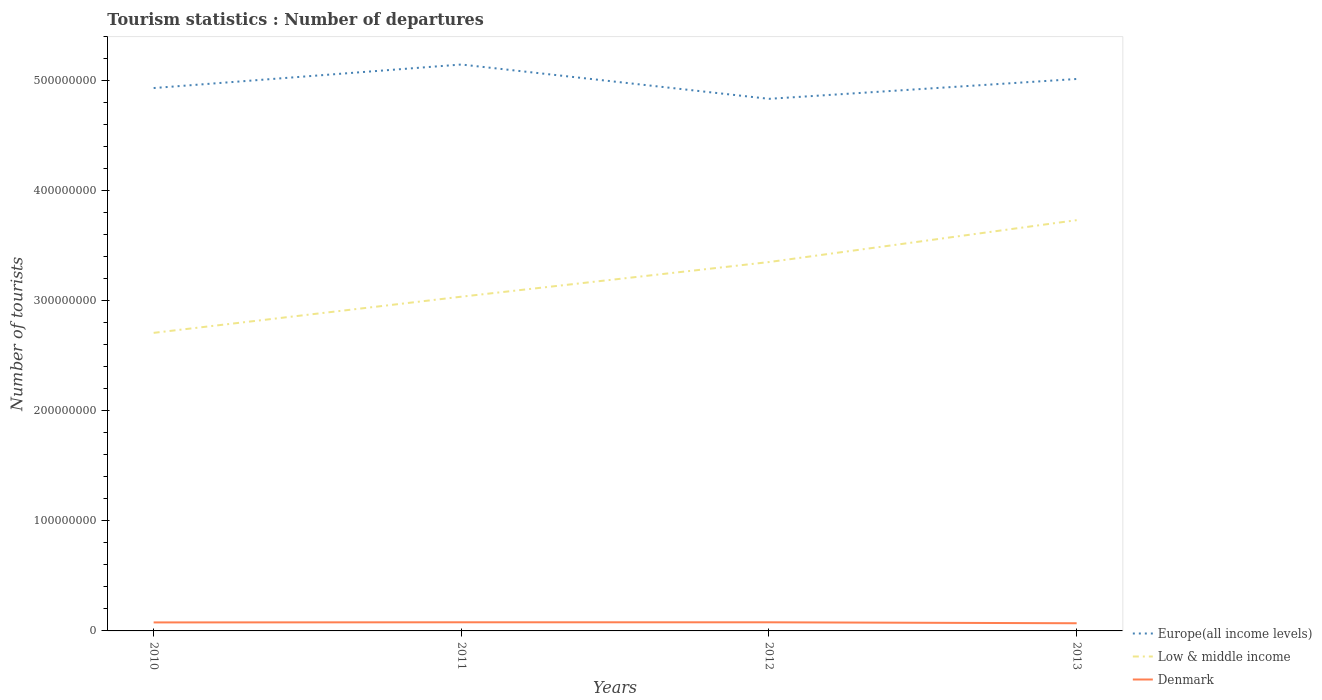Does the line corresponding to Denmark intersect with the line corresponding to Low & middle income?
Provide a succinct answer. No. Across all years, what is the maximum number of tourist departures in Europe(all income levels)?
Offer a very short reply. 4.84e+08. What is the total number of tourist departures in Low & middle income in the graph?
Provide a succinct answer. -6.96e+07. What is the difference between the highest and the second highest number of tourist departures in Denmark?
Offer a very short reply. 8.69e+05. What is the difference between the highest and the lowest number of tourist departures in Europe(all income levels)?
Ensure brevity in your answer.  2. How many lines are there?
Your answer should be compact. 3. How many years are there in the graph?
Make the answer very short. 4. Are the values on the major ticks of Y-axis written in scientific E-notation?
Your answer should be compact. No. Where does the legend appear in the graph?
Ensure brevity in your answer.  Bottom right. How are the legend labels stacked?
Ensure brevity in your answer.  Vertical. What is the title of the graph?
Give a very brief answer. Tourism statistics : Number of departures. What is the label or title of the Y-axis?
Ensure brevity in your answer.  Number of tourists. What is the Number of tourists of Europe(all income levels) in 2010?
Keep it short and to the point. 4.93e+08. What is the Number of tourists in Low & middle income in 2010?
Ensure brevity in your answer.  2.71e+08. What is the Number of tourists in Denmark in 2010?
Make the answer very short. 7.73e+06. What is the Number of tourists of Europe(all income levels) in 2011?
Ensure brevity in your answer.  5.15e+08. What is the Number of tourists in Low & middle income in 2011?
Provide a short and direct response. 3.04e+08. What is the Number of tourists of Denmark in 2011?
Your answer should be compact. 7.85e+06. What is the Number of tourists in Europe(all income levels) in 2012?
Your response must be concise. 4.84e+08. What is the Number of tourists of Low & middle income in 2012?
Ensure brevity in your answer.  3.35e+08. What is the Number of tourists of Denmark in 2012?
Keep it short and to the point. 7.84e+06. What is the Number of tourists in Europe(all income levels) in 2013?
Your answer should be compact. 5.02e+08. What is the Number of tourists in Low & middle income in 2013?
Provide a short and direct response. 3.73e+08. What is the Number of tourists of Denmark in 2013?
Give a very brief answer. 6.98e+06. Across all years, what is the maximum Number of tourists of Europe(all income levels)?
Provide a succinct answer. 5.15e+08. Across all years, what is the maximum Number of tourists in Low & middle income?
Make the answer very short. 3.73e+08. Across all years, what is the maximum Number of tourists in Denmark?
Provide a short and direct response. 7.85e+06. Across all years, what is the minimum Number of tourists in Europe(all income levels)?
Offer a very short reply. 4.84e+08. Across all years, what is the minimum Number of tourists of Low & middle income?
Your answer should be very brief. 2.71e+08. Across all years, what is the minimum Number of tourists of Denmark?
Offer a terse response. 6.98e+06. What is the total Number of tourists of Europe(all income levels) in the graph?
Your answer should be compact. 1.99e+09. What is the total Number of tourists in Low & middle income in the graph?
Your answer should be very brief. 1.28e+09. What is the total Number of tourists in Denmark in the graph?
Provide a succinct answer. 3.04e+07. What is the difference between the Number of tourists of Europe(all income levels) in 2010 and that in 2011?
Provide a succinct answer. -2.14e+07. What is the difference between the Number of tourists of Low & middle income in 2010 and that in 2011?
Provide a succinct answer. -3.29e+07. What is the difference between the Number of tourists of Denmark in 2010 and that in 2011?
Your answer should be very brief. -1.20e+05. What is the difference between the Number of tourists in Europe(all income levels) in 2010 and that in 2012?
Offer a terse response. 9.80e+06. What is the difference between the Number of tourists in Low & middle income in 2010 and that in 2012?
Make the answer very short. -6.44e+07. What is the difference between the Number of tourists in Denmark in 2010 and that in 2012?
Give a very brief answer. -1.17e+05. What is the difference between the Number of tourists in Europe(all income levels) in 2010 and that in 2013?
Make the answer very short. -8.24e+06. What is the difference between the Number of tourists of Low & middle income in 2010 and that in 2013?
Provide a short and direct response. -1.02e+08. What is the difference between the Number of tourists in Denmark in 2010 and that in 2013?
Ensure brevity in your answer.  7.49e+05. What is the difference between the Number of tourists in Europe(all income levels) in 2011 and that in 2012?
Keep it short and to the point. 3.12e+07. What is the difference between the Number of tourists in Low & middle income in 2011 and that in 2012?
Your response must be concise. -3.15e+07. What is the difference between the Number of tourists in Denmark in 2011 and that in 2012?
Provide a succinct answer. 3000. What is the difference between the Number of tourists in Europe(all income levels) in 2011 and that in 2013?
Provide a succinct answer. 1.31e+07. What is the difference between the Number of tourists in Low & middle income in 2011 and that in 2013?
Offer a terse response. -6.96e+07. What is the difference between the Number of tourists of Denmark in 2011 and that in 2013?
Offer a terse response. 8.69e+05. What is the difference between the Number of tourists in Europe(all income levels) in 2012 and that in 2013?
Your response must be concise. -1.80e+07. What is the difference between the Number of tourists of Low & middle income in 2012 and that in 2013?
Provide a short and direct response. -3.81e+07. What is the difference between the Number of tourists of Denmark in 2012 and that in 2013?
Give a very brief answer. 8.66e+05. What is the difference between the Number of tourists in Europe(all income levels) in 2010 and the Number of tourists in Low & middle income in 2011?
Provide a short and direct response. 1.90e+08. What is the difference between the Number of tourists in Europe(all income levels) in 2010 and the Number of tourists in Denmark in 2011?
Make the answer very short. 4.86e+08. What is the difference between the Number of tourists in Low & middle income in 2010 and the Number of tourists in Denmark in 2011?
Offer a terse response. 2.63e+08. What is the difference between the Number of tourists in Europe(all income levels) in 2010 and the Number of tourists in Low & middle income in 2012?
Your answer should be very brief. 1.58e+08. What is the difference between the Number of tourists in Europe(all income levels) in 2010 and the Number of tourists in Denmark in 2012?
Provide a succinct answer. 4.86e+08. What is the difference between the Number of tourists of Low & middle income in 2010 and the Number of tourists of Denmark in 2012?
Provide a succinct answer. 2.63e+08. What is the difference between the Number of tourists in Europe(all income levels) in 2010 and the Number of tourists in Low & middle income in 2013?
Ensure brevity in your answer.  1.20e+08. What is the difference between the Number of tourists in Europe(all income levels) in 2010 and the Number of tourists in Denmark in 2013?
Your answer should be compact. 4.86e+08. What is the difference between the Number of tourists of Low & middle income in 2010 and the Number of tourists of Denmark in 2013?
Your answer should be compact. 2.64e+08. What is the difference between the Number of tourists of Europe(all income levels) in 2011 and the Number of tourists of Low & middle income in 2012?
Provide a short and direct response. 1.80e+08. What is the difference between the Number of tourists of Europe(all income levels) in 2011 and the Number of tourists of Denmark in 2012?
Provide a succinct answer. 5.07e+08. What is the difference between the Number of tourists of Low & middle income in 2011 and the Number of tourists of Denmark in 2012?
Provide a short and direct response. 2.96e+08. What is the difference between the Number of tourists in Europe(all income levels) in 2011 and the Number of tourists in Low & middle income in 2013?
Your answer should be very brief. 1.41e+08. What is the difference between the Number of tourists in Europe(all income levels) in 2011 and the Number of tourists in Denmark in 2013?
Your answer should be very brief. 5.08e+08. What is the difference between the Number of tourists of Low & middle income in 2011 and the Number of tourists of Denmark in 2013?
Provide a short and direct response. 2.97e+08. What is the difference between the Number of tourists of Europe(all income levels) in 2012 and the Number of tourists of Low & middle income in 2013?
Provide a short and direct response. 1.10e+08. What is the difference between the Number of tourists of Europe(all income levels) in 2012 and the Number of tourists of Denmark in 2013?
Keep it short and to the point. 4.77e+08. What is the difference between the Number of tourists in Low & middle income in 2012 and the Number of tourists in Denmark in 2013?
Your answer should be very brief. 3.28e+08. What is the average Number of tourists of Europe(all income levels) per year?
Provide a short and direct response. 4.98e+08. What is the average Number of tourists in Low & middle income per year?
Make the answer very short. 3.21e+08. What is the average Number of tourists in Denmark per year?
Give a very brief answer. 7.60e+06. In the year 2010, what is the difference between the Number of tourists of Europe(all income levels) and Number of tourists of Low & middle income?
Make the answer very short. 2.22e+08. In the year 2010, what is the difference between the Number of tourists of Europe(all income levels) and Number of tourists of Denmark?
Ensure brevity in your answer.  4.86e+08. In the year 2010, what is the difference between the Number of tourists of Low & middle income and Number of tourists of Denmark?
Make the answer very short. 2.63e+08. In the year 2011, what is the difference between the Number of tourists in Europe(all income levels) and Number of tourists in Low & middle income?
Offer a very short reply. 2.11e+08. In the year 2011, what is the difference between the Number of tourists in Europe(all income levels) and Number of tourists in Denmark?
Provide a succinct answer. 5.07e+08. In the year 2011, what is the difference between the Number of tourists in Low & middle income and Number of tourists in Denmark?
Provide a short and direct response. 2.96e+08. In the year 2012, what is the difference between the Number of tourists of Europe(all income levels) and Number of tourists of Low & middle income?
Offer a very short reply. 1.48e+08. In the year 2012, what is the difference between the Number of tourists of Europe(all income levels) and Number of tourists of Denmark?
Your response must be concise. 4.76e+08. In the year 2012, what is the difference between the Number of tourists in Low & middle income and Number of tourists in Denmark?
Ensure brevity in your answer.  3.27e+08. In the year 2013, what is the difference between the Number of tourists of Europe(all income levels) and Number of tourists of Low & middle income?
Your answer should be very brief. 1.28e+08. In the year 2013, what is the difference between the Number of tourists of Europe(all income levels) and Number of tourists of Denmark?
Offer a terse response. 4.95e+08. In the year 2013, what is the difference between the Number of tourists in Low & middle income and Number of tourists in Denmark?
Give a very brief answer. 3.66e+08. What is the ratio of the Number of tourists of Europe(all income levels) in 2010 to that in 2011?
Your answer should be compact. 0.96. What is the ratio of the Number of tourists of Low & middle income in 2010 to that in 2011?
Your answer should be compact. 0.89. What is the ratio of the Number of tourists of Denmark in 2010 to that in 2011?
Your answer should be compact. 0.98. What is the ratio of the Number of tourists of Europe(all income levels) in 2010 to that in 2012?
Give a very brief answer. 1.02. What is the ratio of the Number of tourists in Low & middle income in 2010 to that in 2012?
Offer a terse response. 0.81. What is the ratio of the Number of tourists of Denmark in 2010 to that in 2012?
Provide a short and direct response. 0.99. What is the ratio of the Number of tourists in Europe(all income levels) in 2010 to that in 2013?
Give a very brief answer. 0.98. What is the ratio of the Number of tourists in Low & middle income in 2010 to that in 2013?
Offer a very short reply. 0.73. What is the ratio of the Number of tourists in Denmark in 2010 to that in 2013?
Your answer should be compact. 1.11. What is the ratio of the Number of tourists of Europe(all income levels) in 2011 to that in 2012?
Make the answer very short. 1.06. What is the ratio of the Number of tourists of Low & middle income in 2011 to that in 2012?
Give a very brief answer. 0.91. What is the ratio of the Number of tourists of Europe(all income levels) in 2011 to that in 2013?
Provide a succinct answer. 1.03. What is the ratio of the Number of tourists of Low & middle income in 2011 to that in 2013?
Provide a succinct answer. 0.81. What is the ratio of the Number of tourists of Denmark in 2011 to that in 2013?
Offer a terse response. 1.12. What is the ratio of the Number of tourists of Europe(all income levels) in 2012 to that in 2013?
Offer a very short reply. 0.96. What is the ratio of the Number of tourists of Low & middle income in 2012 to that in 2013?
Offer a very short reply. 0.9. What is the ratio of the Number of tourists in Denmark in 2012 to that in 2013?
Offer a very short reply. 1.12. What is the difference between the highest and the second highest Number of tourists in Europe(all income levels)?
Your answer should be very brief. 1.31e+07. What is the difference between the highest and the second highest Number of tourists of Low & middle income?
Your response must be concise. 3.81e+07. What is the difference between the highest and the second highest Number of tourists of Denmark?
Your answer should be very brief. 3000. What is the difference between the highest and the lowest Number of tourists in Europe(all income levels)?
Provide a succinct answer. 3.12e+07. What is the difference between the highest and the lowest Number of tourists of Low & middle income?
Provide a succinct answer. 1.02e+08. What is the difference between the highest and the lowest Number of tourists in Denmark?
Your answer should be very brief. 8.69e+05. 